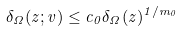<formula> <loc_0><loc_0><loc_500><loc_500>\delta _ { \Omega } ( z ; v ) \leq c _ { 0 } \delta _ { \Omega } ( z ) ^ { 1 / m _ { 0 } }</formula> 